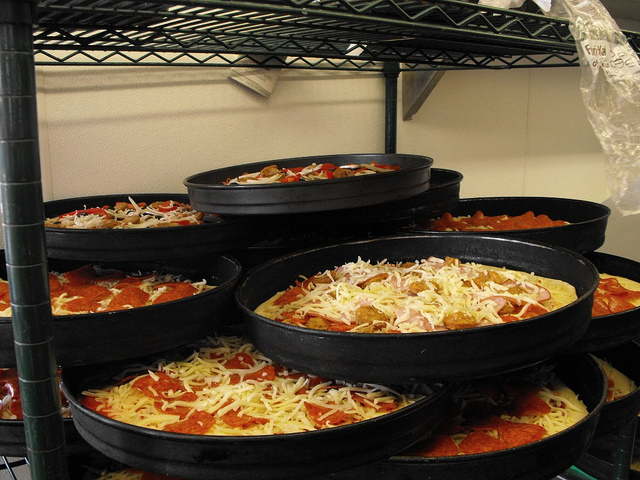Please provide the bounding box coordinate of the region this sentence describes: the pizza closest to the front with pepperoni. The closest pizza to the front decorated with pepperoni slices sits prominently towards the lower-middle of the image [0.1, 0.64, 0.69, 0.81], easily noticeable by its bright red sauce and melted cheese peeking through the toppings. 